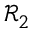Convert formula to latex. <formula><loc_0><loc_0><loc_500><loc_500>\mathcal { R } _ { 2 }</formula> 